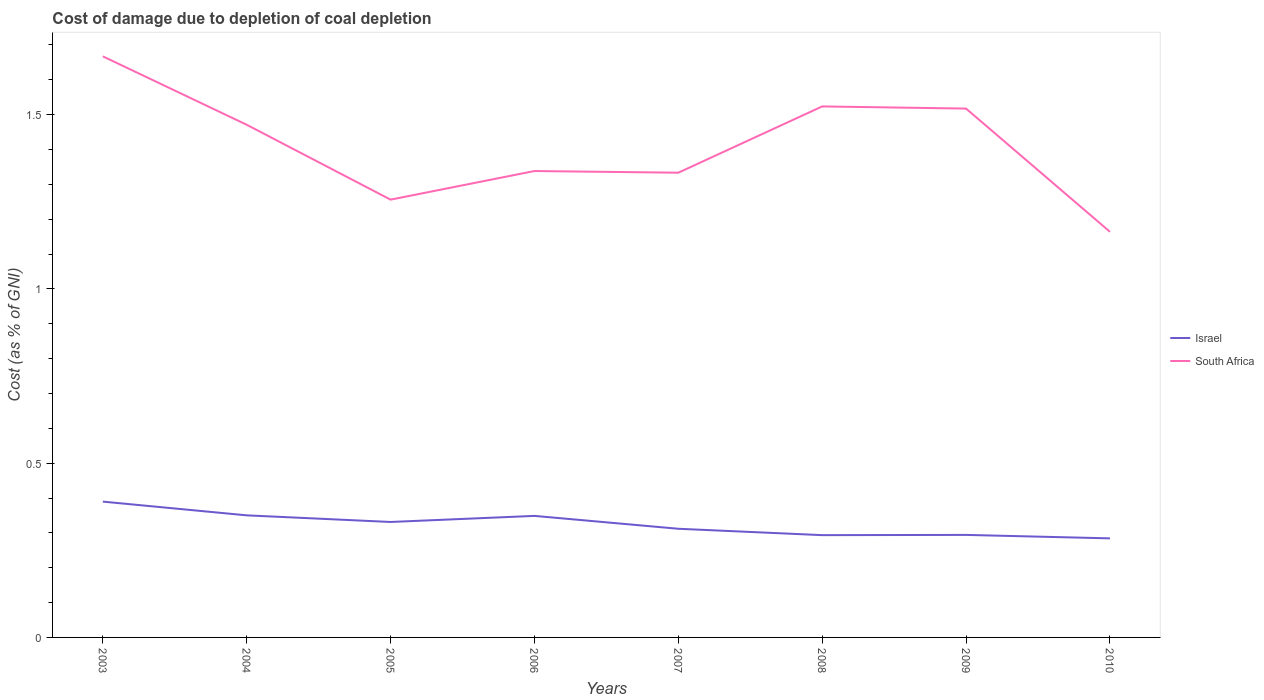How many different coloured lines are there?
Offer a terse response. 2. Across all years, what is the maximum cost of damage caused due to coal depletion in Israel?
Your answer should be compact. 0.28. In which year was the cost of damage caused due to coal depletion in Israel maximum?
Give a very brief answer. 2010. What is the total cost of damage caused due to coal depletion in South Africa in the graph?
Ensure brevity in your answer.  0.2. What is the difference between the highest and the second highest cost of damage caused due to coal depletion in Israel?
Ensure brevity in your answer.  0.11. How many lines are there?
Make the answer very short. 2. What is the difference between two consecutive major ticks on the Y-axis?
Keep it short and to the point. 0.5. Are the values on the major ticks of Y-axis written in scientific E-notation?
Your response must be concise. No. Does the graph contain grids?
Your answer should be compact. No. Where does the legend appear in the graph?
Give a very brief answer. Center right. How are the legend labels stacked?
Your response must be concise. Vertical. What is the title of the graph?
Your answer should be compact. Cost of damage due to depletion of coal depletion. What is the label or title of the X-axis?
Your response must be concise. Years. What is the label or title of the Y-axis?
Provide a short and direct response. Cost (as % of GNI). What is the Cost (as % of GNI) of Israel in 2003?
Ensure brevity in your answer.  0.39. What is the Cost (as % of GNI) in South Africa in 2003?
Make the answer very short. 1.67. What is the Cost (as % of GNI) in Israel in 2004?
Offer a very short reply. 0.35. What is the Cost (as % of GNI) of South Africa in 2004?
Offer a very short reply. 1.47. What is the Cost (as % of GNI) in Israel in 2005?
Provide a short and direct response. 0.33. What is the Cost (as % of GNI) in South Africa in 2005?
Provide a succinct answer. 1.26. What is the Cost (as % of GNI) in Israel in 2006?
Your response must be concise. 0.35. What is the Cost (as % of GNI) of South Africa in 2006?
Provide a short and direct response. 1.34. What is the Cost (as % of GNI) of Israel in 2007?
Ensure brevity in your answer.  0.31. What is the Cost (as % of GNI) in South Africa in 2007?
Offer a very short reply. 1.33. What is the Cost (as % of GNI) in Israel in 2008?
Offer a terse response. 0.29. What is the Cost (as % of GNI) in South Africa in 2008?
Provide a short and direct response. 1.52. What is the Cost (as % of GNI) in Israel in 2009?
Ensure brevity in your answer.  0.29. What is the Cost (as % of GNI) in South Africa in 2009?
Offer a terse response. 1.52. What is the Cost (as % of GNI) in Israel in 2010?
Give a very brief answer. 0.28. What is the Cost (as % of GNI) of South Africa in 2010?
Ensure brevity in your answer.  1.16. Across all years, what is the maximum Cost (as % of GNI) of Israel?
Your response must be concise. 0.39. Across all years, what is the maximum Cost (as % of GNI) of South Africa?
Your response must be concise. 1.67. Across all years, what is the minimum Cost (as % of GNI) in Israel?
Provide a succinct answer. 0.28. Across all years, what is the minimum Cost (as % of GNI) of South Africa?
Make the answer very short. 1.16. What is the total Cost (as % of GNI) in Israel in the graph?
Keep it short and to the point. 2.6. What is the total Cost (as % of GNI) in South Africa in the graph?
Make the answer very short. 11.27. What is the difference between the Cost (as % of GNI) of Israel in 2003 and that in 2004?
Provide a short and direct response. 0.04. What is the difference between the Cost (as % of GNI) of South Africa in 2003 and that in 2004?
Make the answer very short. 0.2. What is the difference between the Cost (as % of GNI) of Israel in 2003 and that in 2005?
Provide a short and direct response. 0.06. What is the difference between the Cost (as % of GNI) of South Africa in 2003 and that in 2005?
Make the answer very short. 0.41. What is the difference between the Cost (as % of GNI) in Israel in 2003 and that in 2006?
Your response must be concise. 0.04. What is the difference between the Cost (as % of GNI) of South Africa in 2003 and that in 2006?
Provide a succinct answer. 0.33. What is the difference between the Cost (as % of GNI) of Israel in 2003 and that in 2007?
Provide a succinct answer. 0.08. What is the difference between the Cost (as % of GNI) in South Africa in 2003 and that in 2007?
Offer a very short reply. 0.33. What is the difference between the Cost (as % of GNI) of Israel in 2003 and that in 2008?
Make the answer very short. 0.1. What is the difference between the Cost (as % of GNI) in South Africa in 2003 and that in 2008?
Provide a short and direct response. 0.14. What is the difference between the Cost (as % of GNI) of Israel in 2003 and that in 2009?
Your response must be concise. 0.1. What is the difference between the Cost (as % of GNI) in South Africa in 2003 and that in 2009?
Provide a succinct answer. 0.15. What is the difference between the Cost (as % of GNI) of Israel in 2003 and that in 2010?
Provide a succinct answer. 0.11. What is the difference between the Cost (as % of GNI) in South Africa in 2003 and that in 2010?
Your answer should be compact. 0.5. What is the difference between the Cost (as % of GNI) in Israel in 2004 and that in 2005?
Provide a short and direct response. 0.02. What is the difference between the Cost (as % of GNI) of South Africa in 2004 and that in 2005?
Your response must be concise. 0.21. What is the difference between the Cost (as % of GNI) of Israel in 2004 and that in 2006?
Offer a very short reply. 0. What is the difference between the Cost (as % of GNI) of South Africa in 2004 and that in 2006?
Your answer should be very brief. 0.13. What is the difference between the Cost (as % of GNI) of Israel in 2004 and that in 2007?
Provide a short and direct response. 0.04. What is the difference between the Cost (as % of GNI) in South Africa in 2004 and that in 2007?
Offer a terse response. 0.14. What is the difference between the Cost (as % of GNI) of Israel in 2004 and that in 2008?
Offer a terse response. 0.06. What is the difference between the Cost (as % of GNI) in South Africa in 2004 and that in 2008?
Provide a short and direct response. -0.05. What is the difference between the Cost (as % of GNI) in Israel in 2004 and that in 2009?
Your answer should be very brief. 0.06. What is the difference between the Cost (as % of GNI) in South Africa in 2004 and that in 2009?
Ensure brevity in your answer.  -0.05. What is the difference between the Cost (as % of GNI) in Israel in 2004 and that in 2010?
Offer a terse response. 0.07. What is the difference between the Cost (as % of GNI) in South Africa in 2004 and that in 2010?
Your answer should be very brief. 0.31. What is the difference between the Cost (as % of GNI) in Israel in 2005 and that in 2006?
Provide a succinct answer. -0.02. What is the difference between the Cost (as % of GNI) in South Africa in 2005 and that in 2006?
Offer a very short reply. -0.08. What is the difference between the Cost (as % of GNI) of Israel in 2005 and that in 2007?
Keep it short and to the point. 0.02. What is the difference between the Cost (as % of GNI) in South Africa in 2005 and that in 2007?
Give a very brief answer. -0.08. What is the difference between the Cost (as % of GNI) in Israel in 2005 and that in 2008?
Give a very brief answer. 0.04. What is the difference between the Cost (as % of GNI) in South Africa in 2005 and that in 2008?
Your response must be concise. -0.27. What is the difference between the Cost (as % of GNI) of Israel in 2005 and that in 2009?
Make the answer very short. 0.04. What is the difference between the Cost (as % of GNI) of South Africa in 2005 and that in 2009?
Your answer should be very brief. -0.26. What is the difference between the Cost (as % of GNI) of Israel in 2005 and that in 2010?
Keep it short and to the point. 0.05. What is the difference between the Cost (as % of GNI) in South Africa in 2005 and that in 2010?
Make the answer very short. 0.09. What is the difference between the Cost (as % of GNI) in Israel in 2006 and that in 2007?
Make the answer very short. 0.04. What is the difference between the Cost (as % of GNI) of South Africa in 2006 and that in 2007?
Ensure brevity in your answer.  0. What is the difference between the Cost (as % of GNI) of Israel in 2006 and that in 2008?
Offer a very short reply. 0.06. What is the difference between the Cost (as % of GNI) of South Africa in 2006 and that in 2008?
Your answer should be very brief. -0.19. What is the difference between the Cost (as % of GNI) of Israel in 2006 and that in 2009?
Your answer should be very brief. 0.05. What is the difference between the Cost (as % of GNI) of South Africa in 2006 and that in 2009?
Provide a succinct answer. -0.18. What is the difference between the Cost (as % of GNI) of Israel in 2006 and that in 2010?
Your answer should be compact. 0.06. What is the difference between the Cost (as % of GNI) in South Africa in 2006 and that in 2010?
Your answer should be very brief. 0.17. What is the difference between the Cost (as % of GNI) in Israel in 2007 and that in 2008?
Your answer should be compact. 0.02. What is the difference between the Cost (as % of GNI) of South Africa in 2007 and that in 2008?
Provide a short and direct response. -0.19. What is the difference between the Cost (as % of GNI) of Israel in 2007 and that in 2009?
Provide a succinct answer. 0.02. What is the difference between the Cost (as % of GNI) of South Africa in 2007 and that in 2009?
Your answer should be very brief. -0.18. What is the difference between the Cost (as % of GNI) in Israel in 2007 and that in 2010?
Your answer should be compact. 0.03. What is the difference between the Cost (as % of GNI) in South Africa in 2007 and that in 2010?
Your answer should be very brief. 0.17. What is the difference between the Cost (as % of GNI) of Israel in 2008 and that in 2009?
Make the answer very short. -0. What is the difference between the Cost (as % of GNI) of South Africa in 2008 and that in 2009?
Keep it short and to the point. 0.01. What is the difference between the Cost (as % of GNI) in Israel in 2008 and that in 2010?
Give a very brief answer. 0.01. What is the difference between the Cost (as % of GNI) in South Africa in 2008 and that in 2010?
Offer a terse response. 0.36. What is the difference between the Cost (as % of GNI) in Israel in 2009 and that in 2010?
Ensure brevity in your answer.  0.01. What is the difference between the Cost (as % of GNI) in South Africa in 2009 and that in 2010?
Provide a succinct answer. 0.35. What is the difference between the Cost (as % of GNI) in Israel in 2003 and the Cost (as % of GNI) in South Africa in 2004?
Provide a succinct answer. -1.08. What is the difference between the Cost (as % of GNI) of Israel in 2003 and the Cost (as % of GNI) of South Africa in 2005?
Keep it short and to the point. -0.87. What is the difference between the Cost (as % of GNI) of Israel in 2003 and the Cost (as % of GNI) of South Africa in 2006?
Offer a terse response. -0.95. What is the difference between the Cost (as % of GNI) in Israel in 2003 and the Cost (as % of GNI) in South Africa in 2007?
Your answer should be very brief. -0.94. What is the difference between the Cost (as % of GNI) of Israel in 2003 and the Cost (as % of GNI) of South Africa in 2008?
Keep it short and to the point. -1.13. What is the difference between the Cost (as % of GNI) in Israel in 2003 and the Cost (as % of GNI) in South Africa in 2009?
Give a very brief answer. -1.13. What is the difference between the Cost (as % of GNI) of Israel in 2003 and the Cost (as % of GNI) of South Africa in 2010?
Offer a terse response. -0.77. What is the difference between the Cost (as % of GNI) in Israel in 2004 and the Cost (as % of GNI) in South Africa in 2005?
Make the answer very short. -0.91. What is the difference between the Cost (as % of GNI) in Israel in 2004 and the Cost (as % of GNI) in South Africa in 2006?
Provide a short and direct response. -0.99. What is the difference between the Cost (as % of GNI) of Israel in 2004 and the Cost (as % of GNI) of South Africa in 2007?
Provide a succinct answer. -0.98. What is the difference between the Cost (as % of GNI) in Israel in 2004 and the Cost (as % of GNI) in South Africa in 2008?
Provide a short and direct response. -1.17. What is the difference between the Cost (as % of GNI) in Israel in 2004 and the Cost (as % of GNI) in South Africa in 2009?
Keep it short and to the point. -1.17. What is the difference between the Cost (as % of GNI) of Israel in 2004 and the Cost (as % of GNI) of South Africa in 2010?
Ensure brevity in your answer.  -0.81. What is the difference between the Cost (as % of GNI) of Israel in 2005 and the Cost (as % of GNI) of South Africa in 2006?
Offer a terse response. -1.01. What is the difference between the Cost (as % of GNI) of Israel in 2005 and the Cost (as % of GNI) of South Africa in 2007?
Your answer should be very brief. -1. What is the difference between the Cost (as % of GNI) of Israel in 2005 and the Cost (as % of GNI) of South Africa in 2008?
Ensure brevity in your answer.  -1.19. What is the difference between the Cost (as % of GNI) of Israel in 2005 and the Cost (as % of GNI) of South Africa in 2009?
Give a very brief answer. -1.19. What is the difference between the Cost (as % of GNI) of Israel in 2005 and the Cost (as % of GNI) of South Africa in 2010?
Your response must be concise. -0.83. What is the difference between the Cost (as % of GNI) of Israel in 2006 and the Cost (as % of GNI) of South Africa in 2007?
Make the answer very short. -0.98. What is the difference between the Cost (as % of GNI) of Israel in 2006 and the Cost (as % of GNI) of South Africa in 2008?
Give a very brief answer. -1.17. What is the difference between the Cost (as % of GNI) of Israel in 2006 and the Cost (as % of GNI) of South Africa in 2009?
Provide a succinct answer. -1.17. What is the difference between the Cost (as % of GNI) in Israel in 2006 and the Cost (as % of GNI) in South Africa in 2010?
Provide a short and direct response. -0.82. What is the difference between the Cost (as % of GNI) of Israel in 2007 and the Cost (as % of GNI) of South Africa in 2008?
Give a very brief answer. -1.21. What is the difference between the Cost (as % of GNI) in Israel in 2007 and the Cost (as % of GNI) in South Africa in 2009?
Offer a terse response. -1.21. What is the difference between the Cost (as % of GNI) of Israel in 2007 and the Cost (as % of GNI) of South Africa in 2010?
Ensure brevity in your answer.  -0.85. What is the difference between the Cost (as % of GNI) in Israel in 2008 and the Cost (as % of GNI) in South Africa in 2009?
Offer a terse response. -1.22. What is the difference between the Cost (as % of GNI) of Israel in 2008 and the Cost (as % of GNI) of South Africa in 2010?
Ensure brevity in your answer.  -0.87. What is the difference between the Cost (as % of GNI) of Israel in 2009 and the Cost (as % of GNI) of South Africa in 2010?
Offer a terse response. -0.87. What is the average Cost (as % of GNI) of Israel per year?
Give a very brief answer. 0.33. What is the average Cost (as % of GNI) of South Africa per year?
Keep it short and to the point. 1.41. In the year 2003, what is the difference between the Cost (as % of GNI) in Israel and Cost (as % of GNI) in South Africa?
Ensure brevity in your answer.  -1.28. In the year 2004, what is the difference between the Cost (as % of GNI) of Israel and Cost (as % of GNI) of South Africa?
Offer a terse response. -1.12. In the year 2005, what is the difference between the Cost (as % of GNI) in Israel and Cost (as % of GNI) in South Africa?
Give a very brief answer. -0.92. In the year 2006, what is the difference between the Cost (as % of GNI) in Israel and Cost (as % of GNI) in South Africa?
Give a very brief answer. -0.99. In the year 2007, what is the difference between the Cost (as % of GNI) in Israel and Cost (as % of GNI) in South Africa?
Offer a very short reply. -1.02. In the year 2008, what is the difference between the Cost (as % of GNI) in Israel and Cost (as % of GNI) in South Africa?
Offer a terse response. -1.23. In the year 2009, what is the difference between the Cost (as % of GNI) of Israel and Cost (as % of GNI) of South Africa?
Offer a terse response. -1.22. In the year 2010, what is the difference between the Cost (as % of GNI) in Israel and Cost (as % of GNI) in South Africa?
Keep it short and to the point. -0.88. What is the ratio of the Cost (as % of GNI) of Israel in 2003 to that in 2004?
Your answer should be very brief. 1.11. What is the ratio of the Cost (as % of GNI) of South Africa in 2003 to that in 2004?
Offer a terse response. 1.13. What is the ratio of the Cost (as % of GNI) in Israel in 2003 to that in 2005?
Your answer should be compact. 1.18. What is the ratio of the Cost (as % of GNI) in South Africa in 2003 to that in 2005?
Your response must be concise. 1.33. What is the ratio of the Cost (as % of GNI) in Israel in 2003 to that in 2006?
Your answer should be very brief. 1.12. What is the ratio of the Cost (as % of GNI) in South Africa in 2003 to that in 2006?
Offer a very short reply. 1.25. What is the ratio of the Cost (as % of GNI) in Israel in 2003 to that in 2007?
Your answer should be compact. 1.25. What is the ratio of the Cost (as % of GNI) of South Africa in 2003 to that in 2007?
Offer a terse response. 1.25. What is the ratio of the Cost (as % of GNI) of Israel in 2003 to that in 2008?
Ensure brevity in your answer.  1.33. What is the ratio of the Cost (as % of GNI) of South Africa in 2003 to that in 2008?
Your response must be concise. 1.09. What is the ratio of the Cost (as % of GNI) in Israel in 2003 to that in 2009?
Provide a short and direct response. 1.32. What is the ratio of the Cost (as % of GNI) in South Africa in 2003 to that in 2009?
Keep it short and to the point. 1.1. What is the ratio of the Cost (as % of GNI) of Israel in 2003 to that in 2010?
Keep it short and to the point. 1.37. What is the ratio of the Cost (as % of GNI) in South Africa in 2003 to that in 2010?
Offer a very short reply. 1.43. What is the ratio of the Cost (as % of GNI) of Israel in 2004 to that in 2005?
Your answer should be very brief. 1.06. What is the ratio of the Cost (as % of GNI) in South Africa in 2004 to that in 2005?
Your answer should be very brief. 1.17. What is the ratio of the Cost (as % of GNI) of South Africa in 2004 to that in 2006?
Offer a very short reply. 1.1. What is the ratio of the Cost (as % of GNI) of Israel in 2004 to that in 2007?
Offer a terse response. 1.12. What is the ratio of the Cost (as % of GNI) of South Africa in 2004 to that in 2007?
Offer a very short reply. 1.1. What is the ratio of the Cost (as % of GNI) of Israel in 2004 to that in 2008?
Your answer should be compact. 1.19. What is the ratio of the Cost (as % of GNI) of South Africa in 2004 to that in 2008?
Ensure brevity in your answer.  0.97. What is the ratio of the Cost (as % of GNI) in Israel in 2004 to that in 2009?
Give a very brief answer. 1.19. What is the ratio of the Cost (as % of GNI) in South Africa in 2004 to that in 2009?
Offer a terse response. 0.97. What is the ratio of the Cost (as % of GNI) in Israel in 2004 to that in 2010?
Provide a succinct answer. 1.23. What is the ratio of the Cost (as % of GNI) in South Africa in 2004 to that in 2010?
Offer a terse response. 1.26. What is the ratio of the Cost (as % of GNI) in Israel in 2005 to that in 2006?
Offer a very short reply. 0.95. What is the ratio of the Cost (as % of GNI) in South Africa in 2005 to that in 2006?
Ensure brevity in your answer.  0.94. What is the ratio of the Cost (as % of GNI) of South Africa in 2005 to that in 2007?
Provide a succinct answer. 0.94. What is the ratio of the Cost (as % of GNI) of Israel in 2005 to that in 2008?
Offer a terse response. 1.13. What is the ratio of the Cost (as % of GNI) in South Africa in 2005 to that in 2008?
Offer a terse response. 0.82. What is the ratio of the Cost (as % of GNI) in Israel in 2005 to that in 2009?
Ensure brevity in your answer.  1.13. What is the ratio of the Cost (as % of GNI) in South Africa in 2005 to that in 2009?
Keep it short and to the point. 0.83. What is the ratio of the Cost (as % of GNI) in Israel in 2005 to that in 2010?
Offer a terse response. 1.17. What is the ratio of the Cost (as % of GNI) in South Africa in 2005 to that in 2010?
Your response must be concise. 1.08. What is the ratio of the Cost (as % of GNI) in Israel in 2006 to that in 2007?
Make the answer very short. 1.12. What is the ratio of the Cost (as % of GNI) of Israel in 2006 to that in 2008?
Your answer should be very brief. 1.19. What is the ratio of the Cost (as % of GNI) in South Africa in 2006 to that in 2008?
Give a very brief answer. 0.88. What is the ratio of the Cost (as % of GNI) in Israel in 2006 to that in 2009?
Offer a terse response. 1.19. What is the ratio of the Cost (as % of GNI) in South Africa in 2006 to that in 2009?
Your answer should be compact. 0.88. What is the ratio of the Cost (as % of GNI) of Israel in 2006 to that in 2010?
Your answer should be compact. 1.23. What is the ratio of the Cost (as % of GNI) of South Africa in 2006 to that in 2010?
Ensure brevity in your answer.  1.15. What is the ratio of the Cost (as % of GNI) in Israel in 2007 to that in 2008?
Make the answer very short. 1.06. What is the ratio of the Cost (as % of GNI) in South Africa in 2007 to that in 2008?
Provide a succinct answer. 0.88. What is the ratio of the Cost (as % of GNI) of Israel in 2007 to that in 2009?
Offer a very short reply. 1.06. What is the ratio of the Cost (as % of GNI) of South Africa in 2007 to that in 2009?
Provide a succinct answer. 0.88. What is the ratio of the Cost (as % of GNI) of Israel in 2007 to that in 2010?
Offer a very short reply. 1.1. What is the ratio of the Cost (as % of GNI) in South Africa in 2007 to that in 2010?
Your answer should be very brief. 1.15. What is the ratio of the Cost (as % of GNI) in Israel in 2008 to that in 2009?
Keep it short and to the point. 1. What is the ratio of the Cost (as % of GNI) in South Africa in 2008 to that in 2009?
Provide a succinct answer. 1. What is the ratio of the Cost (as % of GNI) in Israel in 2008 to that in 2010?
Your answer should be very brief. 1.03. What is the ratio of the Cost (as % of GNI) of South Africa in 2008 to that in 2010?
Offer a very short reply. 1.31. What is the ratio of the Cost (as % of GNI) of Israel in 2009 to that in 2010?
Make the answer very short. 1.03. What is the ratio of the Cost (as % of GNI) in South Africa in 2009 to that in 2010?
Make the answer very short. 1.3. What is the difference between the highest and the second highest Cost (as % of GNI) in Israel?
Your answer should be compact. 0.04. What is the difference between the highest and the second highest Cost (as % of GNI) in South Africa?
Your answer should be compact. 0.14. What is the difference between the highest and the lowest Cost (as % of GNI) in Israel?
Your answer should be very brief. 0.11. What is the difference between the highest and the lowest Cost (as % of GNI) in South Africa?
Offer a very short reply. 0.5. 